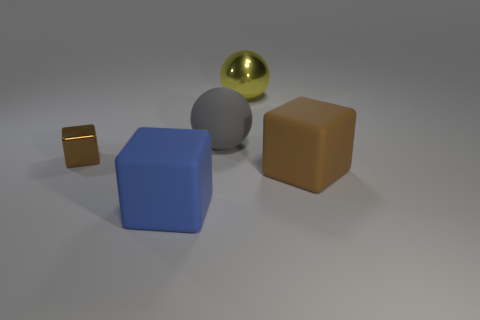What is the material of the large yellow ball?
Provide a short and direct response. Metal. Does the metallic ball have the same color as the large matte object behind the metallic cube?
Provide a succinct answer. No. What number of brown objects are to the left of the large yellow thing?
Make the answer very short. 1. Are there fewer big blue cubes behind the large blue rubber cube than big brown objects?
Provide a succinct answer. Yes. What color is the tiny thing?
Offer a terse response. Brown. There is a large cube right of the large metal object; is it the same color as the small metallic object?
Your answer should be compact. Yes. The tiny thing that is the same shape as the large blue matte object is what color?
Your response must be concise. Brown. What number of large things are gray rubber cylinders or yellow metal spheres?
Keep it short and to the point. 1. How big is the brown object that is to the left of the big brown rubber object?
Provide a succinct answer. Small. Is there a small shiny cube of the same color as the large rubber sphere?
Your answer should be very brief. No. 